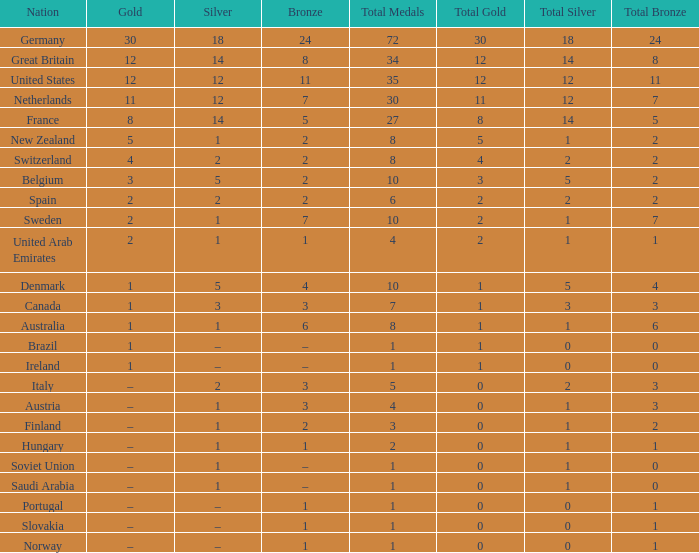What is Gold, when Total is 6? 2.0. 